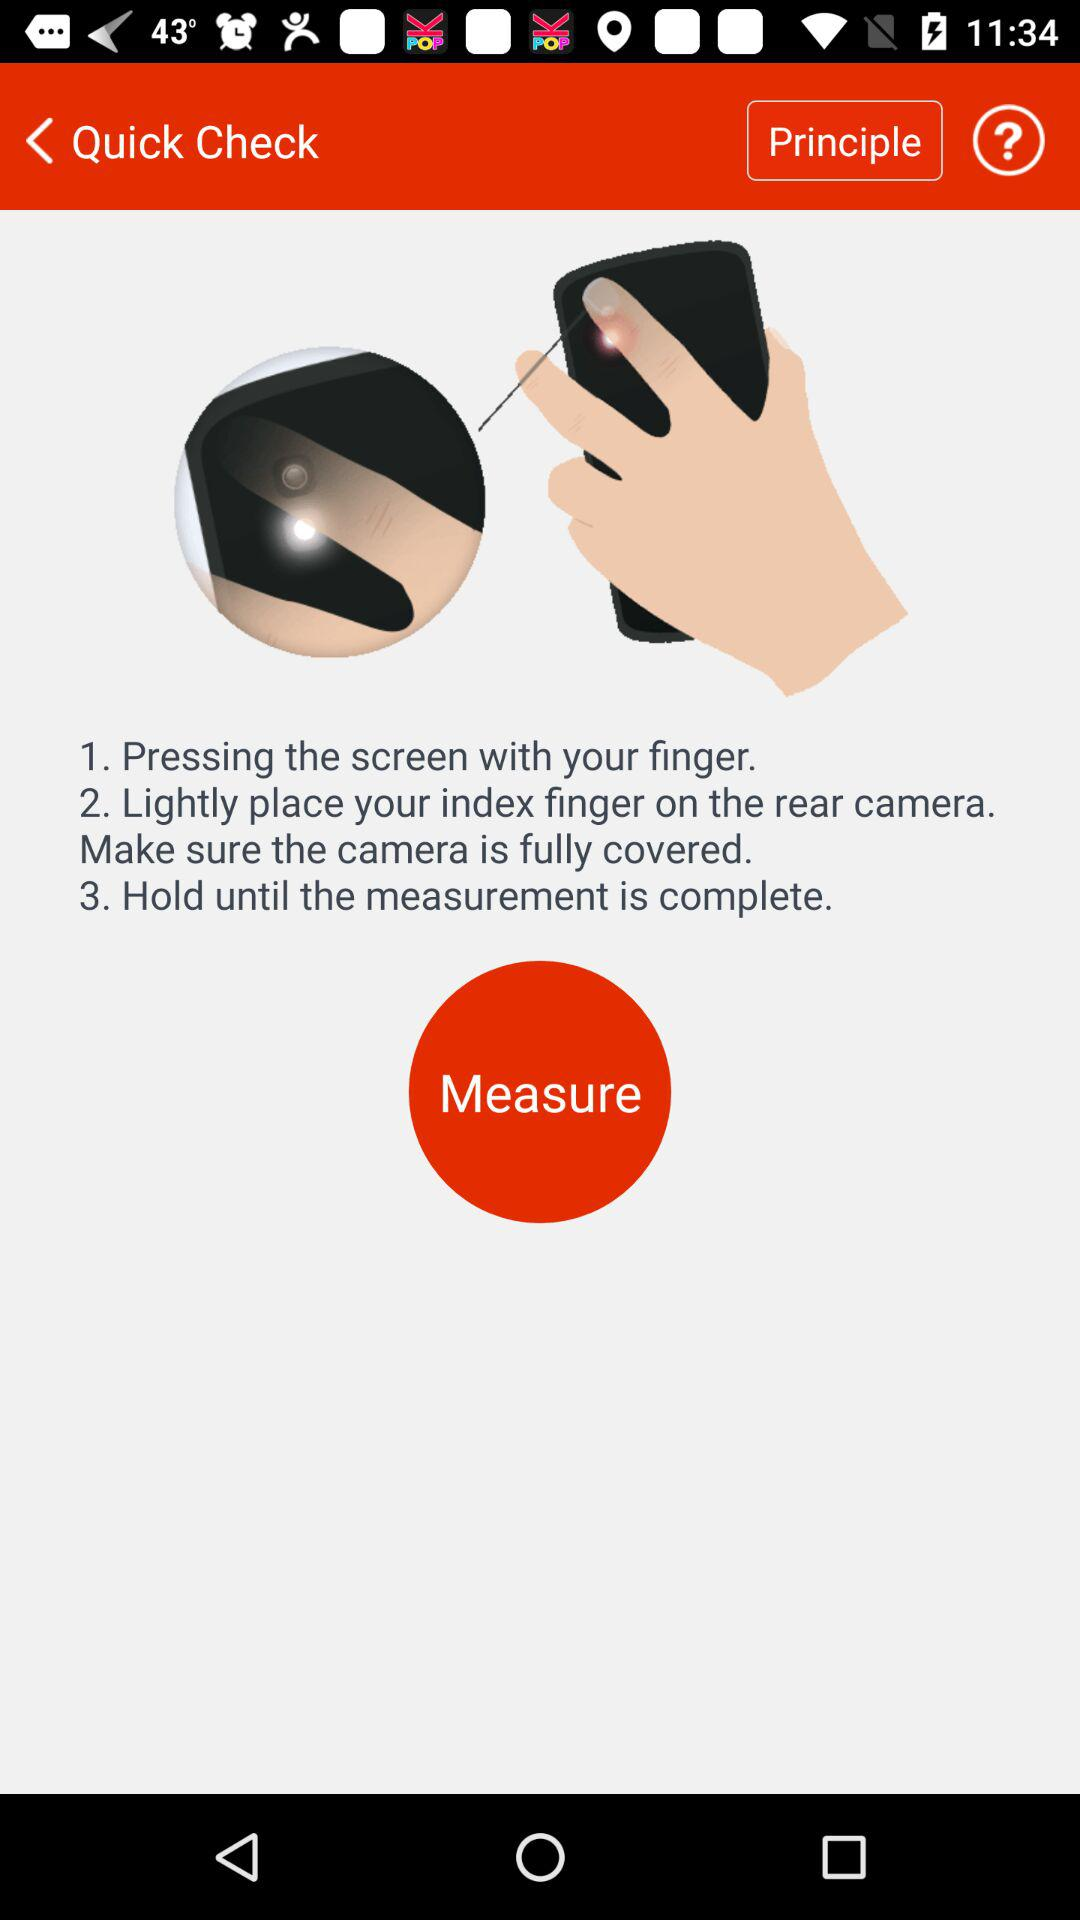How many steps are there in the process of taking a measurement?
Answer the question using a single word or phrase. 3 